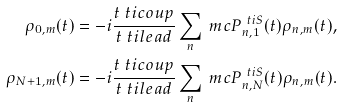Convert formula to latex. <formula><loc_0><loc_0><loc_500><loc_500>\rho _ { 0 , m } ( t ) & = - i \frac { t _ { \ } t i { c o u p } } { t _ { \ } t i { l e a d } } \sum _ { n } \ m c { P } _ { n , 1 } ^ { \ t i { S } } ( t ) \rho _ { n , m } ( t ) , \\ \rho _ { N + 1 , m } ( t ) & = - i \frac { t _ { \ } t i { c o u p } } { t _ { \ } t i { l e a d } } \sum _ { n } \ m c { P } _ { n , N } ^ { \ t i { S } } ( t ) \rho _ { n , m } ( t ) .</formula> 